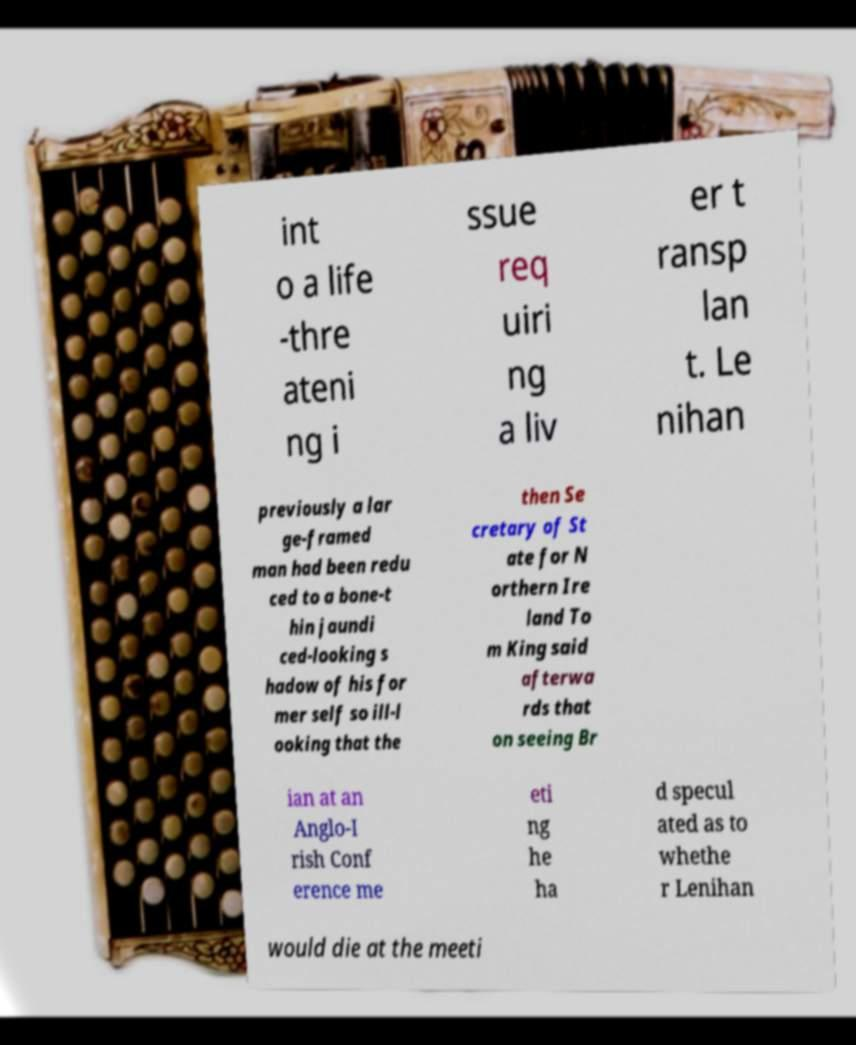There's text embedded in this image that I need extracted. Can you transcribe it verbatim? int o a life -thre ateni ng i ssue req uiri ng a liv er t ransp lan t. Le nihan previously a lar ge-framed man had been redu ced to a bone-t hin jaundi ced-looking s hadow of his for mer self so ill-l ooking that the then Se cretary of St ate for N orthern Ire land To m King said afterwa rds that on seeing Br ian at an Anglo-I rish Conf erence me eti ng he ha d specul ated as to whethe r Lenihan would die at the meeti 